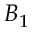<formula> <loc_0><loc_0><loc_500><loc_500>B _ { 1 }</formula> 